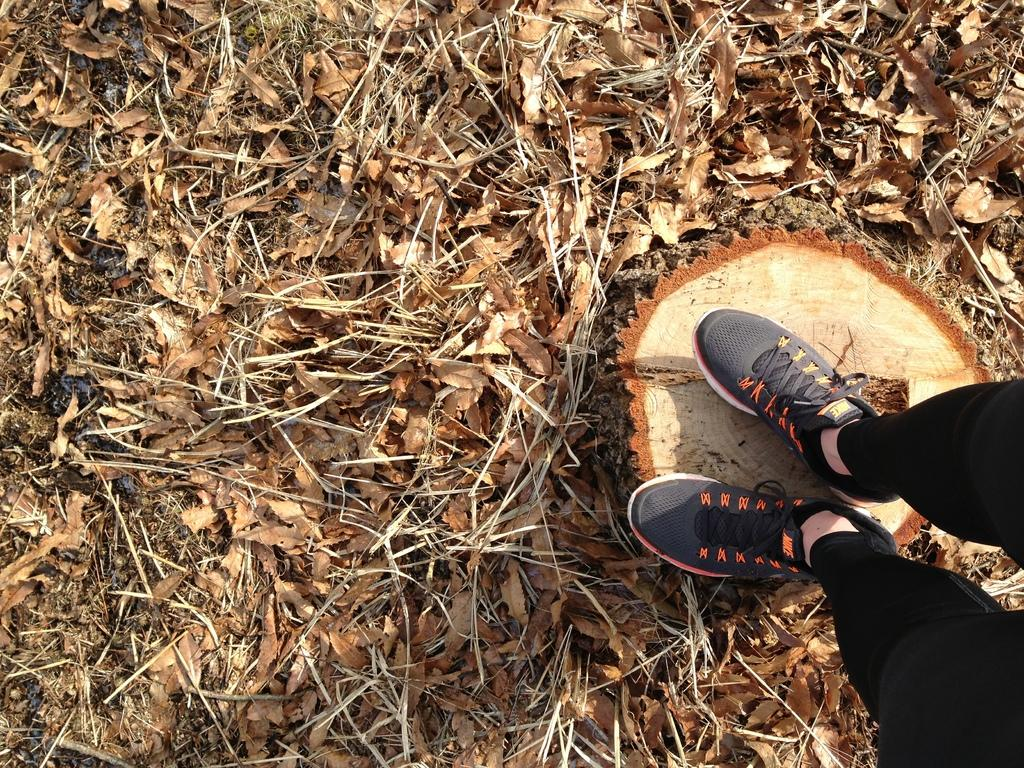What is the person standing on in the image? There is a person standing on a wooden bark in the image. What type of natural elements can be seen in the image? There are leaves visible in the image. What type of cough medicine does the person's aunt recommend in the image? There is no mention of a person's aunt or any cough medicine in the image. 